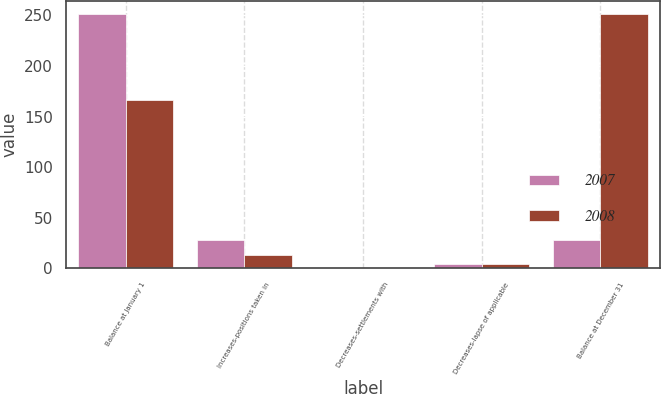<chart> <loc_0><loc_0><loc_500><loc_500><stacked_bar_chart><ecel><fcel>Balance at January 1<fcel>Increases-positions taken in<fcel>Decreases-settlements with<fcel>Decreases-lapse of applicable<fcel>Balance at December 31<nl><fcel>2007<fcel>251.4<fcel>28.4<fcel>0.2<fcel>4.3<fcel>28.4<nl><fcel>2008<fcel>166<fcel>12.8<fcel>0.7<fcel>4.7<fcel>251.4<nl></chart> 